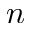Convert formula to latex. <formula><loc_0><loc_0><loc_500><loc_500>n</formula> 